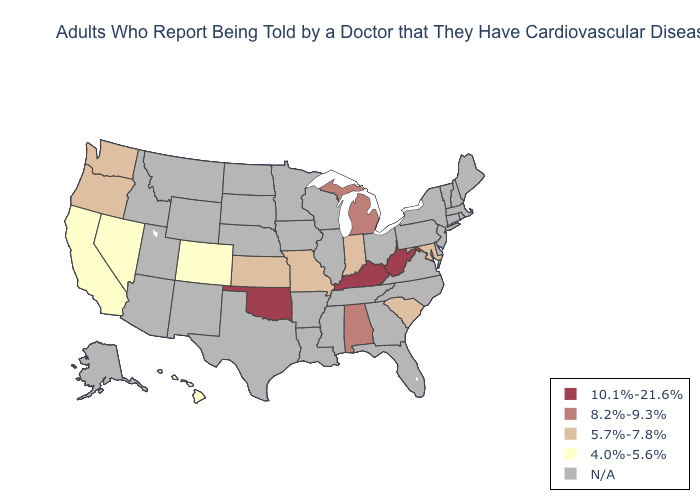How many symbols are there in the legend?
Be succinct. 5. Name the states that have a value in the range 4.0%-5.6%?
Keep it brief. California, Colorado, Hawaii, Nevada. What is the value of Maryland?
Quick response, please. 5.7%-7.8%. Does West Virginia have the highest value in the USA?
Be succinct. Yes. Is the legend a continuous bar?
Give a very brief answer. No. Does Indiana have the highest value in the USA?
Be succinct. No. Is the legend a continuous bar?
Short answer required. No. What is the value of Alaska?
Short answer required. N/A. Which states hav the highest value in the MidWest?
Quick response, please. Michigan. Name the states that have a value in the range N/A?
Concise answer only. Alaska, Arizona, Arkansas, Connecticut, Delaware, Florida, Georgia, Idaho, Illinois, Iowa, Louisiana, Maine, Massachusetts, Minnesota, Mississippi, Montana, Nebraska, New Hampshire, New Jersey, New Mexico, New York, North Carolina, North Dakota, Ohio, Pennsylvania, Rhode Island, South Dakota, Tennessee, Texas, Utah, Vermont, Virginia, Wisconsin, Wyoming. What is the highest value in the USA?
Quick response, please. 10.1%-21.6%. Which states hav the highest value in the South?
Answer briefly. Kentucky, Oklahoma, West Virginia. What is the lowest value in the USA?
Answer briefly. 4.0%-5.6%. 